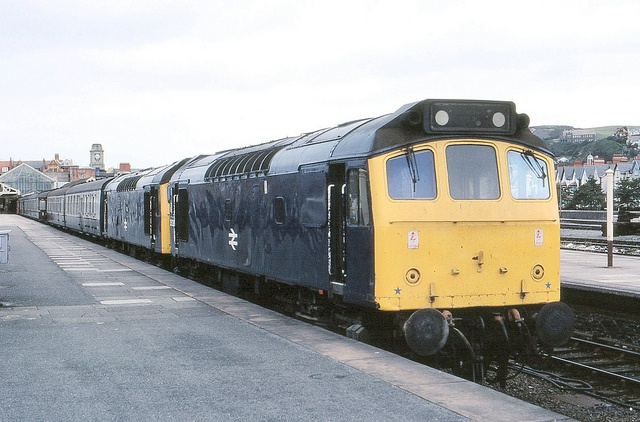Describe the objects in this image and their specific colors. I can see a train in lavender, black, gray, and khaki tones in this image. 